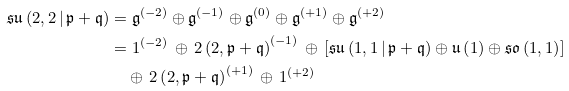<formula> <loc_0><loc_0><loc_500><loc_500>\mathfrak { s u } \left ( 2 , 2 \, | \, \mathfrak { p } + \mathfrak { q } \right ) & = \mathfrak { g } ^ { ( - 2 ) } \oplus \mathfrak { g } ^ { ( - 1 ) } \oplus \mathfrak { g } ^ { ( 0 ) } \oplus \mathfrak { g } ^ { ( + 1 ) } \oplus \mathfrak { g } ^ { ( + 2 ) } \\ & = 1 ^ { ( - 2 ) } \, \oplus \, 2 \left ( 2 , \mathfrak { p } + \mathfrak { q } \right ) ^ { ( - 1 ) } \, \oplus \, \left [ \mathfrak { s u } \left ( 1 , 1 \, | \, \mathfrak { p } + \mathfrak { q } \right ) \oplus \mathfrak { u } \left ( 1 \right ) \oplus \mathfrak { s o } \left ( 1 , 1 \right ) \right ] \\ & \quad \oplus \, 2 \left ( 2 , \mathfrak { p } + \mathfrak { q } \right ) ^ { ( + 1 ) } \, \oplus \, 1 ^ { ( + 2 ) }</formula> 